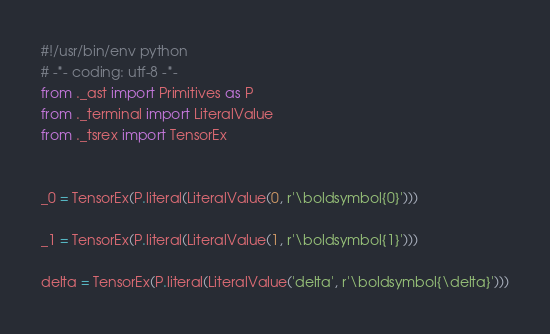Convert code to text. <code><loc_0><loc_0><loc_500><loc_500><_Python_>#!/usr/bin/env python
# -*- coding: utf-8 -*-
from ._ast import Primitives as P
from ._terminal import LiteralValue
from ._tsrex import TensorEx


_0 = TensorEx(P.literal(LiteralValue(0, r'\boldsymbol{0}')))

_1 = TensorEx(P.literal(LiteralValue(1, r'\boldsymbol{1}')))

delta = TensorEx(P.literal(LiteralValue('delta', r'\boldsymbol{\delta}')))
</code> 